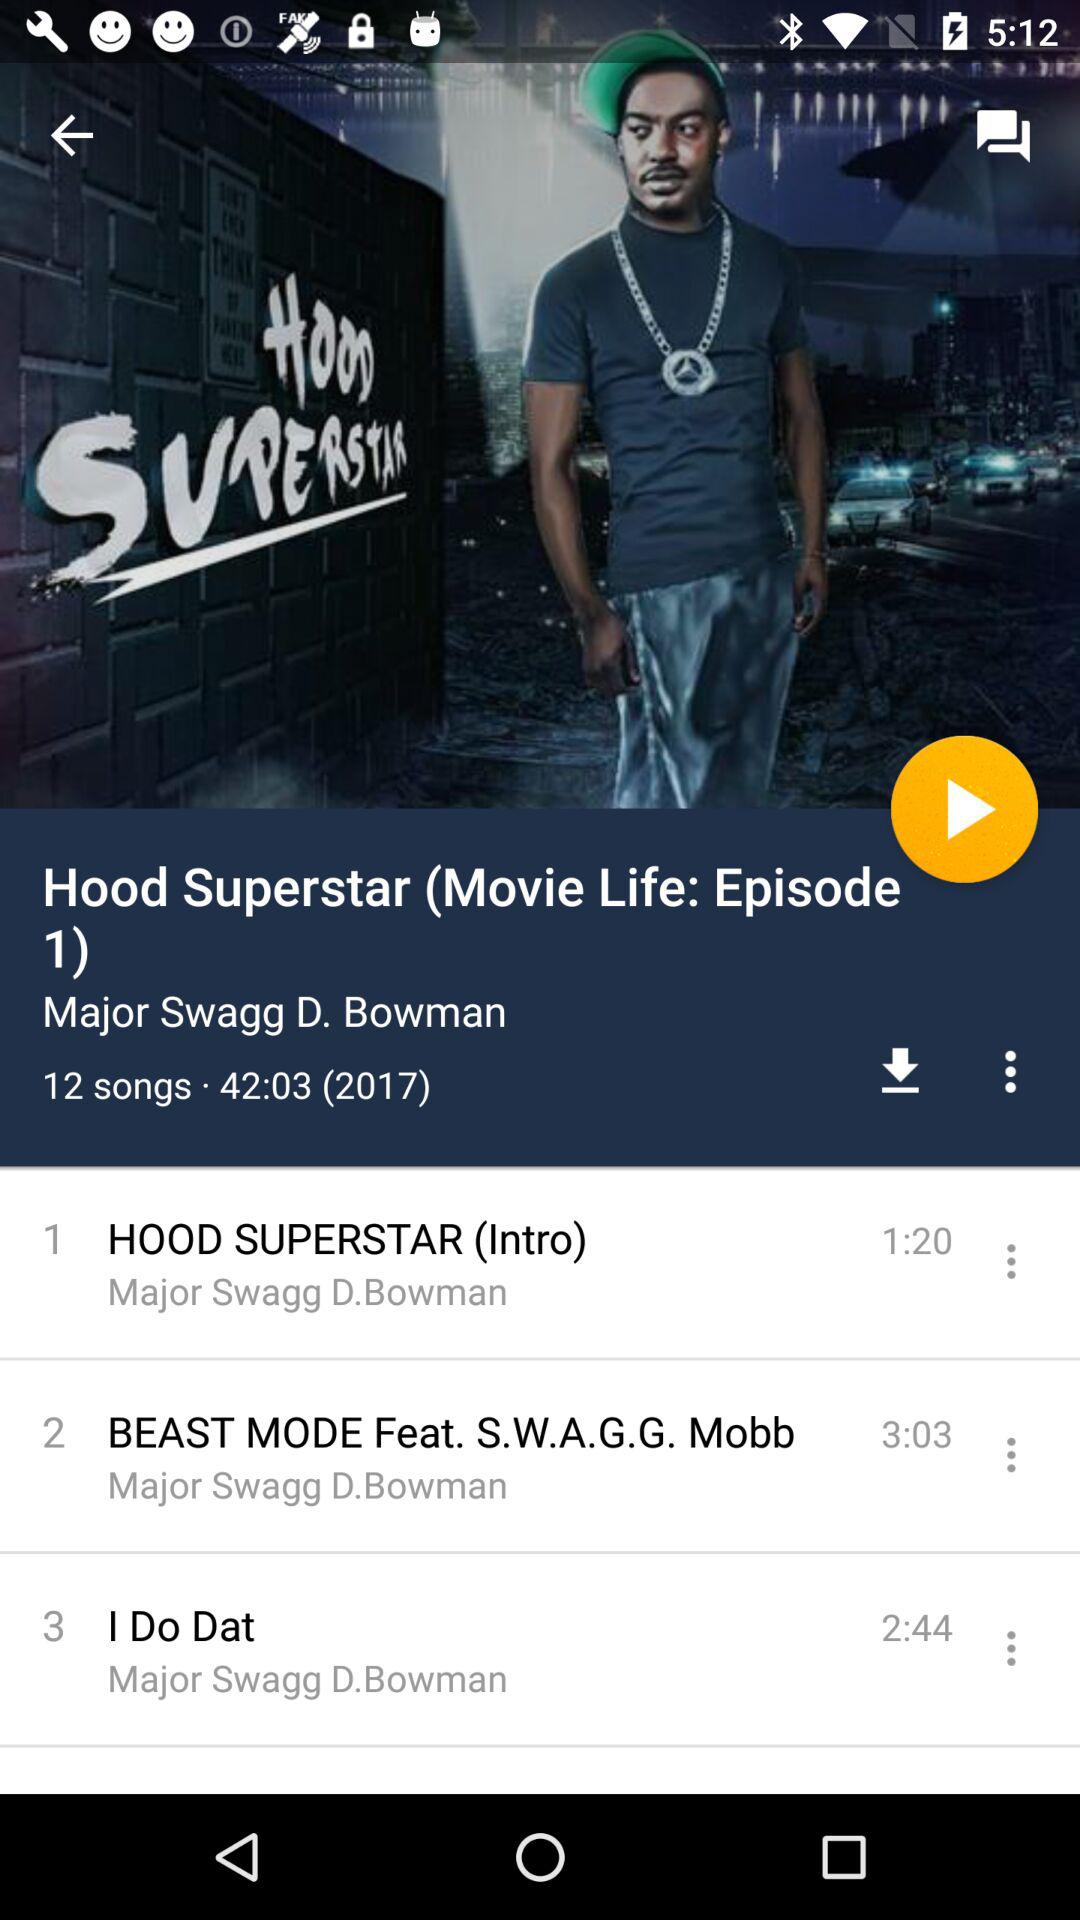How many songs are there in "Hood Superstar"? There are 12 songs in "Hood Superstar". 